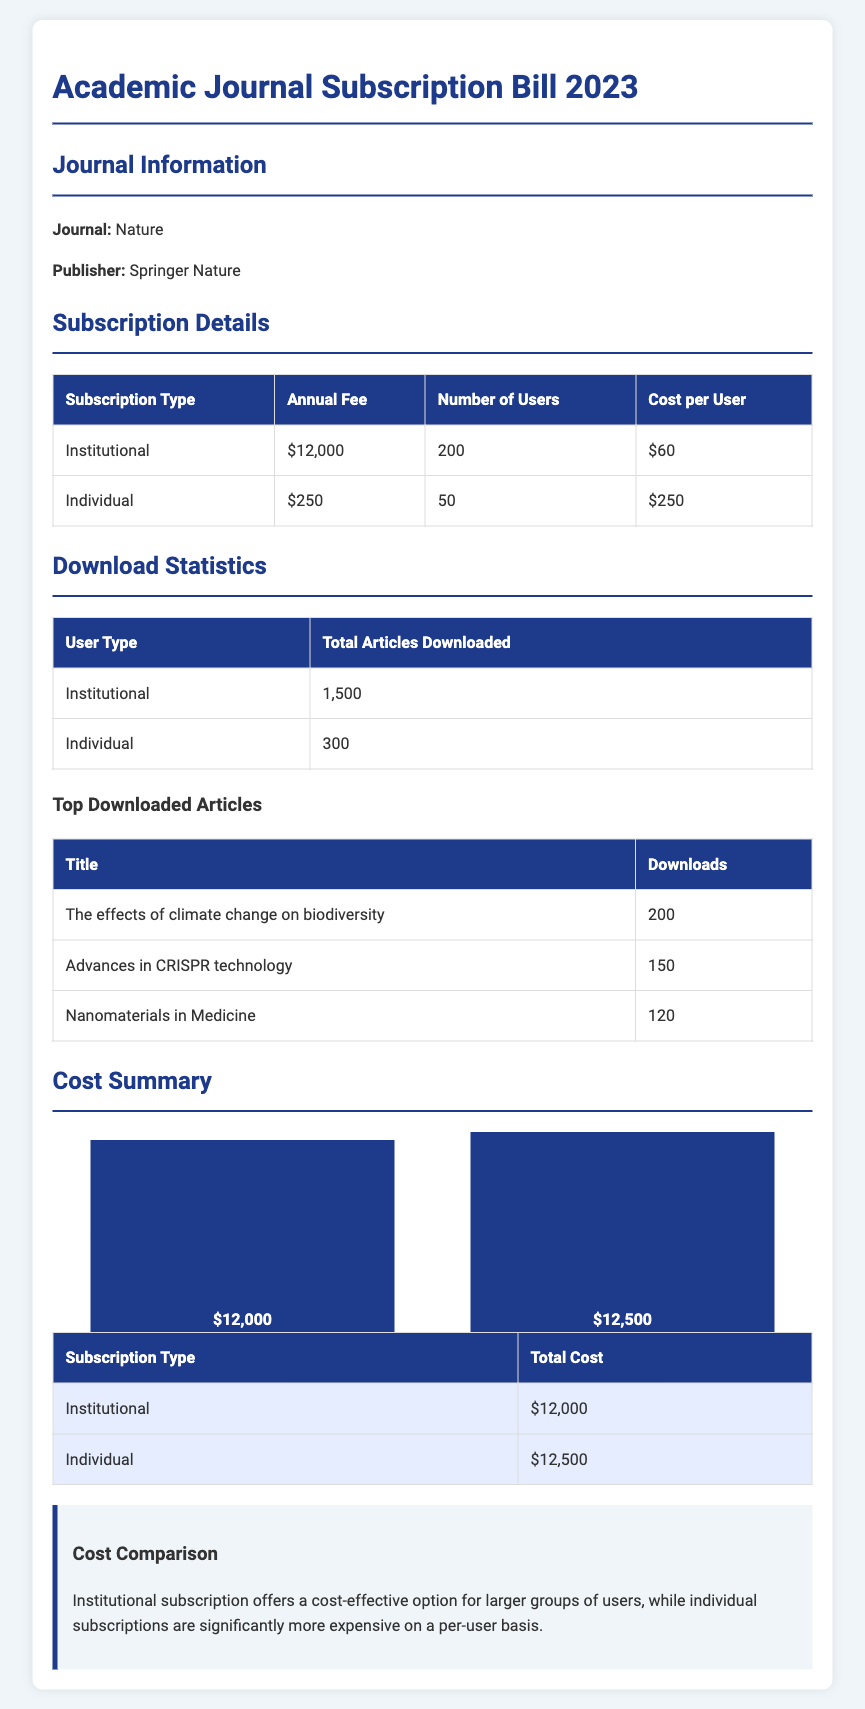What is the journal name? The journal name is mentioned at the beginning of the document under Journal Information.
Answer: Nature What is the annual fee for institutional subscription? The annual fee for institutional subscription is listed in the Subscription Details table.
Answer: $12,000 How many articles were downloaded by individual users? The total articles downloaded by individual users is indicated in the Download Statistics table.
Answer: 300 Which article had the highest number of downloads? The article with the highest downloads is mentioned in the Top Downloaded Articles section.
Answer: The effects of climate change on biodiversity What is the cost per user for the individual subscription? The cost per user for individual subscription is shown in the Subscription Details table.
Answer: $250 What is the total cost for individual subscriptions? The total cost for individual subscriptions is found in the Cost Summary table.
Answer: $12,500 Which subscription type is more cost-effective for a larger group? This refers to the comparison provided in the Cost Summary section of the document.
Answer: Institutional How many users does the institutional subscription cater to? The number of users for the institutional subscription is provided in the Subscription Details table.
Answer: 200 What are the top two downloaded articles? The document lists the top articles and their download statistics.
Answer: The effects of climate change on biodiversity, Advances in CRISPR technology 